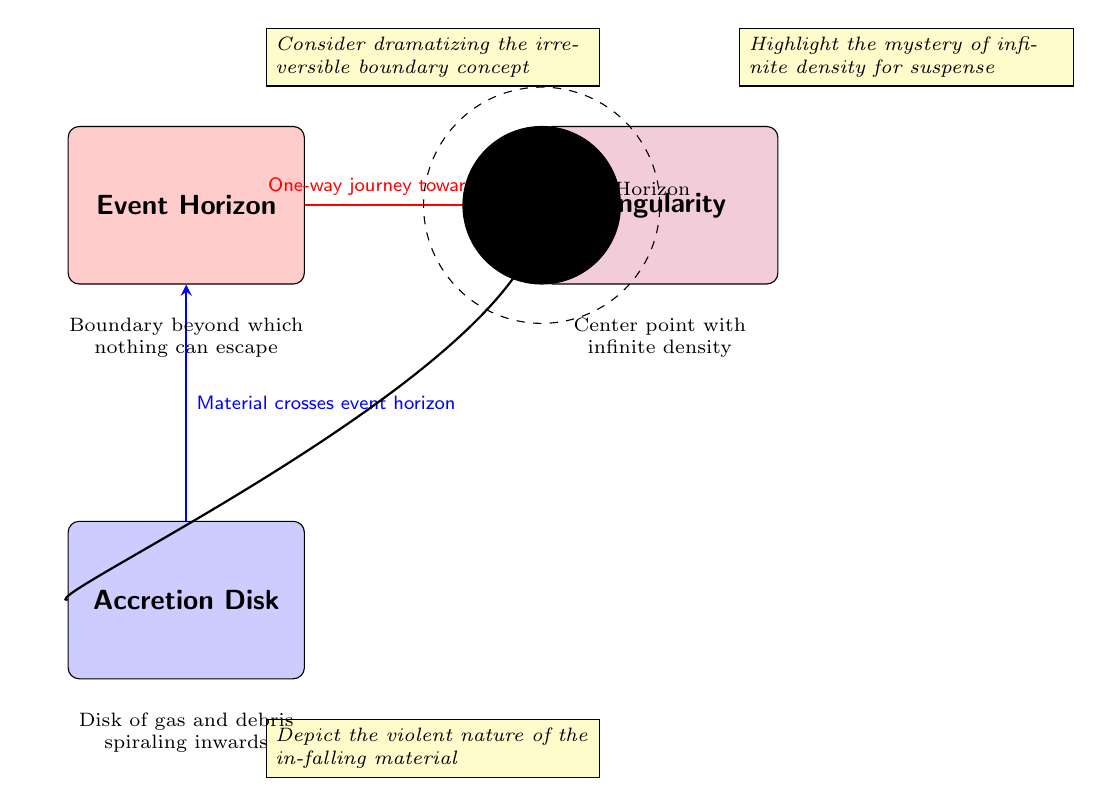What are the components illustrated in the diagram? The diagram shows three main components: Event Horizon, Singularity, and Accretion Disk. Each component is distinctly labeled and colored, making them easily identifiable.
Answer: Event Horizon, Singularity, Accretion Disk What direction does material flow to reach the Singularity? The diagram indicates that there is a one-way journey towards the Singularity from the Event Horizon, emphasized by the arrow pointing from Event Horizon to Singularity.
Answer: One-way journey towards singularity What does the Accretion Disk consist of? According to the annotation, the Accretion Disk is made up of gas and debris spiraling inwards towards the black hole, described as a disk of in-falling material.
Answer: Gas and debris What shape is the Event Horizon in the diagram? The Event Horizon is represented as a dashed circle surrounding the Singularity, indicating a boundary beyond which no escape is possible.
Answer: Dashed circle How many arrows are present in the diagram? There are two arrows shown in the diagram, one pointing from the Event Horizon to the Singularity and the other from the Accretion Disk to the Event Horizon.
Answer: Two arrows What does the annotation near the Event Horizon suggest? The annotation suggests dramatizing the irreversible boundary concept, adding a narrative element that could enhance the storytelling aspect of the diagram.
Answer: Dramatize the irreversible boundary concept What does the annotation next to the Singularity highlight? The annotation highlights the mystery of infinite density, which can create suspense and intrigue in storytelling surrounding this deep space phenomenon.
Answer: Mystery of infinite density What type of flow is represented from the Accretion Disk to the Event Horizon? The flow from the Accretion Disk to the Event Horizon is shown as material crossing over the boundary, indicating a continuous process of infall.
Answer: Material crosses event horizon What can be inferred about the nature of the in-falling material toward the Accretion Disk? The annotation describes the violent nature of the in-falling material, suggesting that it behaves unpredictably and energetically as it spirals inward.
Answer: Violent nature of the in-falling material 